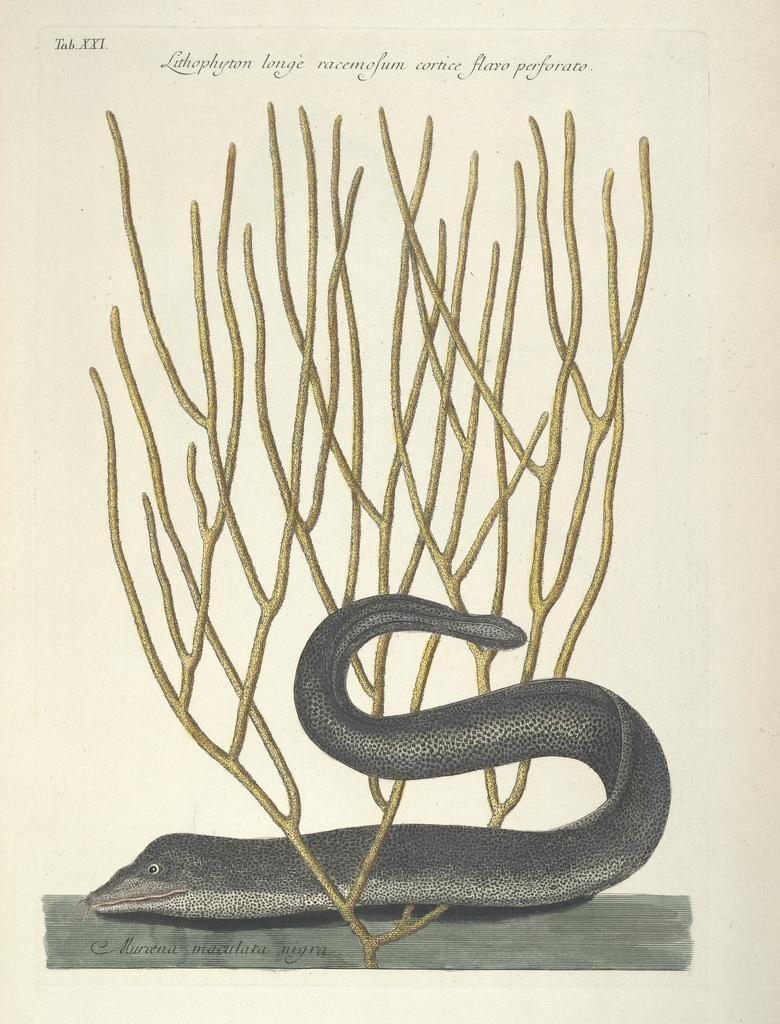What is the main subject of the image? The main subject of the image is a snake. What type of medium might the image be? The image might be a painting in a book. Are there any additional elements on the painting? Yes, there is text written on the painting. How does the snake show its appreciation for the ink in the image? There is no ink present in the image, and snakes do not have the ability to show appreciation. 